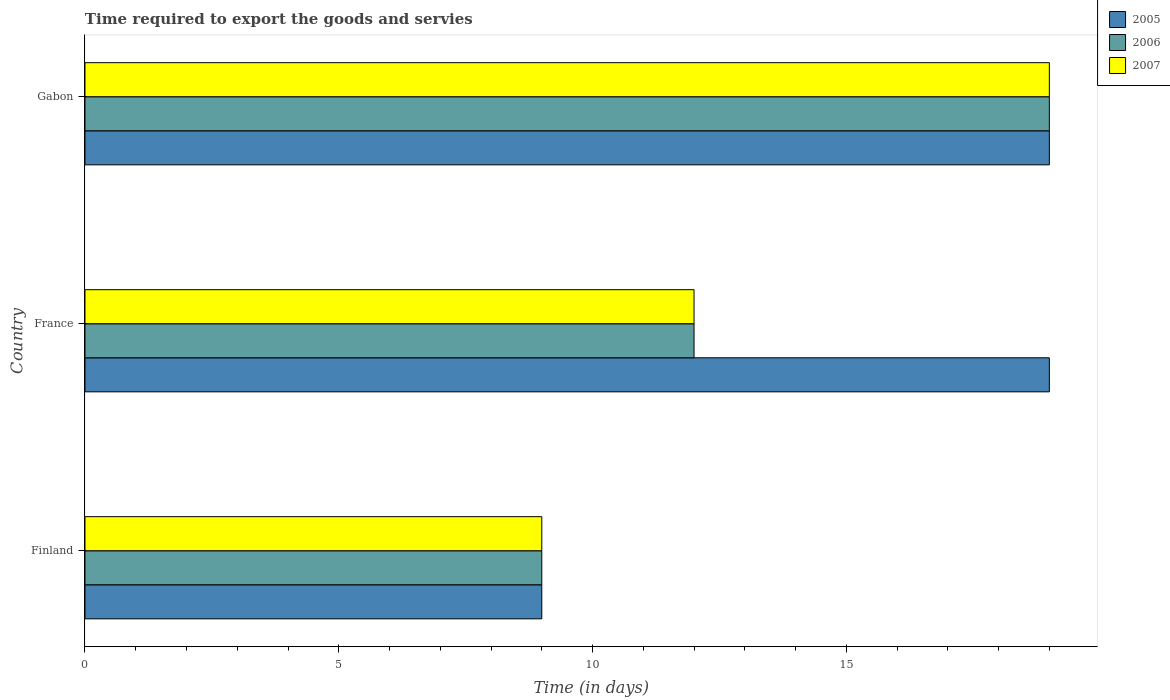Are the number of bars per tick equal to the number of legend labels?
Give a very brief answer. Yes. Are the number of bars on each tick of the Y-axis equal?
Offer a terse response. Yes. In how many cases, is the number of bars for a given country not equal to the number of legend labels?
Your answer should be compact. 0. What is the number of days required to export the goods and services in 2006 in France?
Provide a succinct answer. 12. Across all countries, what is the minimum number of days required to export the goods and services in 2006?
Your response must be concise. 9. In which country was the number of days required to export the goods and services in 2007 maximum?
Provide a succinct answer. Gabon. What is the total number of days required to export the goods and services in 2005 in the graph?
Your answer should be compact. 47. What is the difference between the number of days required to export the goods and services in 2005 in Gabon and the number of days required to export the goods and services in 2006 in France?
Your answer should be very brief. 7. What is the average number of days required to export the goods and services in 2007 per country?
Offer a terse response. 13.33. What is the difference between the number of days required to export the goods and services in 2005 and number of days required to export the goods and services in 2006 in Gabon?
Keep it short and to the point. 0. What is the ratio of the number of days required to export the goods and services in 2005 in Finland to that in Gabon?
Make the answer very short. 0.47. Is the number of days required to export the goods and services in 2007 in France less than that in Gabon?
Ensure brevity in your answer.  Yes. What is the difference between the highest and the second highest number of days required to export the goods and services in 2005?
Your answer should be very brief. 0. What is the difference between the highest and the lowest number of days required to export the goods and services in 2006?
Give a very brief answer. 10. Is it the case that in every country, the sum of the number of days required to export the goods and services in 2006 and number of days required to export the goods and services in 2005 is greater than the number of days required to export the goods and services in 2007?
Offer a very short reply. Yes. How many bars are there?
Provide a short and direct response. 9. Are all the bars in the graph horizontal?
Your answer should be compact. Yes. How many countries are there in the graph?
Your response must be concise. 3. What is the difference between two consecutive major ticks on the X-axis?
Keep it short and to the point. 5. Are the values on the major ticks of X-axis written in scientific E-notation?
Give a very brief answer. No. Where does the legend appear in the graph?
Keep it short and to the point. Top right. How many legend labels are there?
Make the answer very short. 3. What is the title of the graph?
Your response must be concise. Time required to export the goods and servies. What is the label or title of the X-axis?
Your answer should be compact. Time (in days). What is the Time (in days) of 2005 in Finland?
Give a very brief answer. 9. What is the Time (in days) of 2006 in France?
Give a very brief answer. 12. What is the Time (in days) of 2006 in Gabon?
Your answer should be compact. 19. Across all countries, what is the maximum Time (in days) in 2005?
Your answer should be compact. 19. Across all countries, what is the minimum Time (in days) of 2005?
Make the answer very short. 9. Across all countries, what is the minimum Time (in days) of 2006?
Provide a succinct answer. 9. Across all countries, what is the minimum Time (in days) of 2007?
Give a very brief answer. 9. What is the total Time (in days) of 2005 in the graph?
Make the answer very short. 47. What is the total Time (in days) in 2006 in the graph?
Ensure brevity in your answer.  40. What is the difference between the Time (in days) in 2005 in Finland and that in France?
Your response must be concise. -10. What is the difference between the Time (in days) in 2005 in Finland and that in Gabon?
Give a very brief answer. -10. What is the difference between the Time (in days) in 2006 in Finland and that in Gabon?
Make the answer very short. -10. What is the difference between the Time (in days) in 2006 in France and that in Gabon?
Give a very brief answer. -7. What is the difference between the Time (in days) of 2005 in Finland and the Time (in days) of 2007 in France?
Offer a very short reply. -3. What is the difference between the Time (in days) in 2006 in Finland and the Time (in days) in 2007 in France?
Your answer should be very brief. -3. What is the difference between the Time (in days) in 2005 in Finland and the Time (in days) in 2006 in Gabon?
Ensure brevity in your answer.  -10. What is the difference between the Time (in days) in 2005 in Finland and the Time (in days) in 2007 in Gabon?
Make the answer very short. -10. What is the average Time (in days) in 2005 per country?
Your response must be concise. 15.67. What is the average Time (in days) of 2006 per country?
Make the answer very short. 13.33. What is the average Time (in days) of 2007 per country?
Make the answer very short. 13.33. What is the difference between the Time (in days) in 2005 and Time (in days) in 2007 in Finland?
Provide a short and direct response. 0. What is the difference between the Time (in days) of 2006 and Time (in days) of 2007 in France?
Offer a very short reply. 0. What is the difference between the Time (in days) of 2006 and Time (in days) of 2007 in Gabon?
Give a very brief answer. 0. What is the ratio of the Time (in days) of 2005 in Finland to that in France?
Your answer should be very brief. 0.47. What is the ratio of the Time (in days) of 2005 in Finland to that in Gabon?
Your response must be concise. 0.47. What is the ratio of the Time (in days) of 2006 in Finland to that in Gabon?
Your response must be concise. 0.47. What is the ratio of the Time (in days) in 2007 in Finland to that in Gabon?
Keep it short and to the point. 0.47. What is the ratio of the Time (in days) in 2006 in France to that in Gabon?
Give a very brief answer. 0.63. What is the ratio of the Time (in days) of 2007 in France to that in Gabon?
Your answer should be very brief. 0.63. What is the difference between the highest and the second highest Time (in days) in 2005?
Ensure brevity in your answer.  0. What is the difference between the highest and the second highest Time (in days) in 2006?
Keep it short and to the point. 7. What is the difference between the highest and the lowest Time (in days) in 2006?
Give a very brief answer. 10. What is the difference between the highest and the lowest Time (in days) of 2007?
Your answer should be compact. 10. 